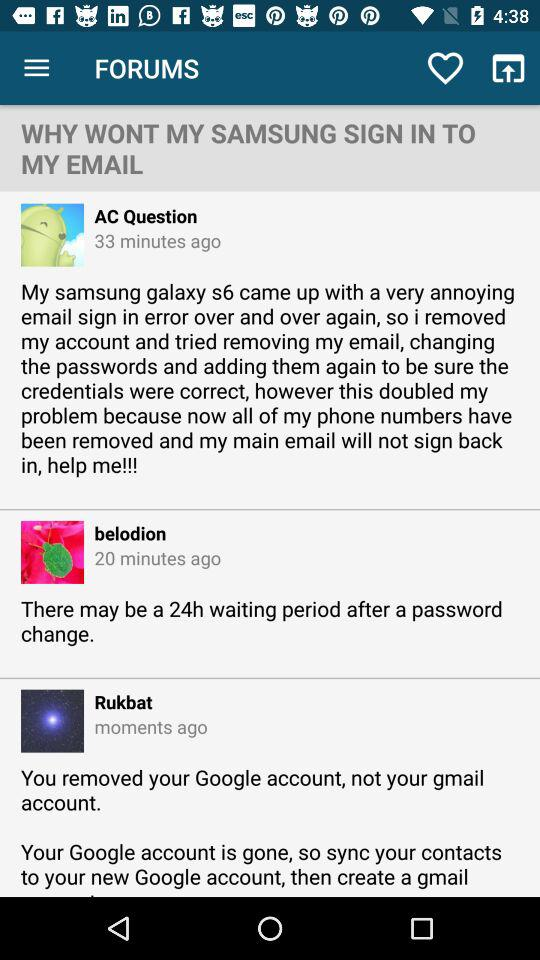How many minutes ago was the last post?
Answer the question using a single word or phrase. Moments ago 